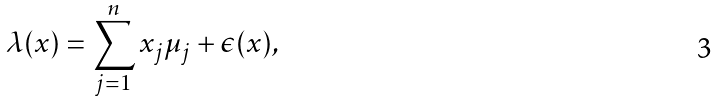Convert formula to latex. <formula><loc_0><loc_0><loc_500><loc_500>\lambda ( x ) = \sum _ { j = 1 } ^ { n } x _ { j } \mu _ { j } + \epsilon ( x ) ,</formula> 